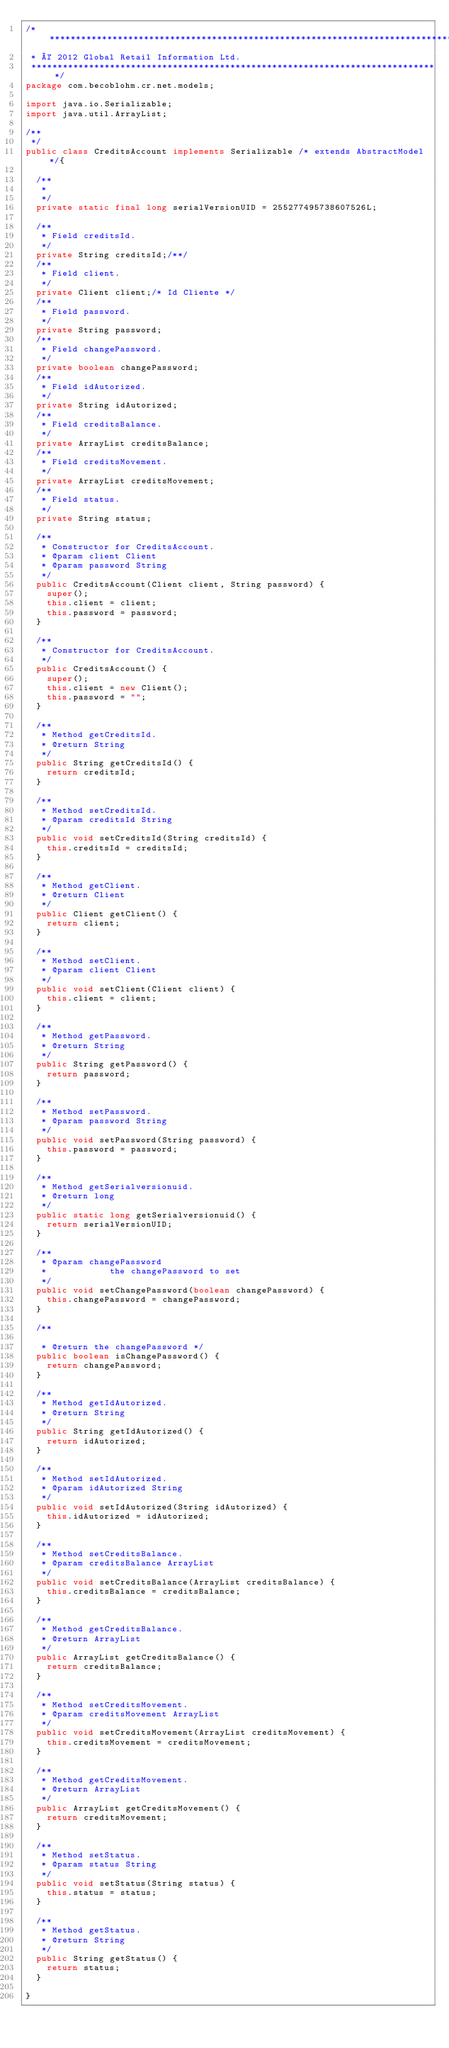Convert code to text. <code><loc_0><loc_0><loc_500><loc_500><_Java_>/*******************************************************************************
 * © 2012 Global Retail Information Ltd.
 ******************************************************************************/
package com.becoblohm.cr.net.models;

import java.io.Serializable;
import java.util.ArrayList;

/**
 */
public class CreditsAccount implements Serializable /* extends AbstractModel */{

	/**
	 * 
	 */
	private static final long serialVersionUID = 255277495738607526L;

	/**
	 * Field creditsId.
	 */
	private String creditsId;/**/
	/**
	 * Field client.
	 */
	private Client client;/* Id Cliente */
	/**
	 * Field password.
	 */
	private String password;
	/**
	 * Field changePassword.
	 */
	private boolean changePassword;
	/**
	 * Field idAutorized.
	 */
	private String idAutorized;
	/**
	 * Field creditsBalance.
	 */
	private ArrayList creditsBalance;
	/**
	 * Field creditsMovement.
	 */
	private ArrayList creditsMovement;
	/**
	 * Field status.
	 */
	private String status;

	/**
	 * Constructor for CreditsAccount.
	 * @param client Client
	 * @param password String
	 */
	public CreditsAccount(Client client, String password) {
		super();
		this.client = client;
		this.password = password;
	}

	/**
	 * Constructor for CreditsAccount.
	 */
	public CreditsAccount() {
		super();
		this.client = new Client();
		this.password = "";
	}

	/**
	 * Method getCreditsId.
	 * @return String
	 */
	public String getCreditsId() {
		return creditsId;
	}

	/**
	 * Method setCreditsId.
	 * @param creditsId String
	 */
	public void setCreditsId(String creditsId) {
		this.creditsId = creditsId;
	}

	/**
	 * Method getClient.
	 * @return Client
	 */
	public Client getClient() {
		return client;
	}

	/**
	 * Method setClient.
	 * @param client Client
	 */
	public void setClient(Client client) {
		this.client = client;
	}

	/**
	 * Method getPassword.
	 * @return String
	 */
	public String getPassword() {
		return password;
	}

	/**
	 * Method setPassword.
	 * @param password String
	 */
	public void setPassword(String password) {
		this.password = password;
	}

	/**
	 * Method getSerialversionuid.
	 * @return long
	 */
	public static long getSerialversionuid() {
		return serialVersionUID;
	}

	/**
	 * @param changePassword
	 *            the changePassword to set
	 */
	public void setChangePassword(boolean changePassword) {
		this.changePassword = changePassword;
	}

	/**
	
	 * @return the changePassword */
	public boolean isChangePassword() {
		return changePassword;
	}

	/**
	 * Method getIdAutorized.
	 * @return String
	 */
	public String getIdAutorized() {
		return idAutorized;
	}

	/**
	 * Method setIdAutorized.
	 * @param idAutorized String
	 */
	public void setIdAutorized(String idAutorized) {
		this.idAutorized = idAutorized;
	}

	/**
	 * Method setCreditsBalance.
	 * @param creditsBalance ArrayList
	 */
	public void setCreditsBalance(ArrayList creditsBalance) {
		this.creditsBalance = creditsBalance;
	}

	/**
	 * Method getCreditsBalance.
	 * @return ArrayList
	 */
	public ArrayList getCreditsBalance() {
		return creditsBalance;
	}

	/**
	 * Method setCreditsMovement.
	 * @param creditsMovement ArrayList
	 */
	public void setCreditsMovement(ArrayList creditsMovement) {
		this.creditsMovement = creditsMovement;
	}

	/**
	 * Method getCreditsMovement.
	 * @return ArrayList
	 */
	public ArrayList getCreditsMovement() {
		return creditsMovement;
	}

	/**
	 * Method setStatus.
	 * @param status String
	 */
	public void setStatus(String status) {
		this.status = status;
	}

	/**
	 * Method getStatus.
	 * @return String
	 */
	public String getStatus() {
		return status;
	}

}
</code> 